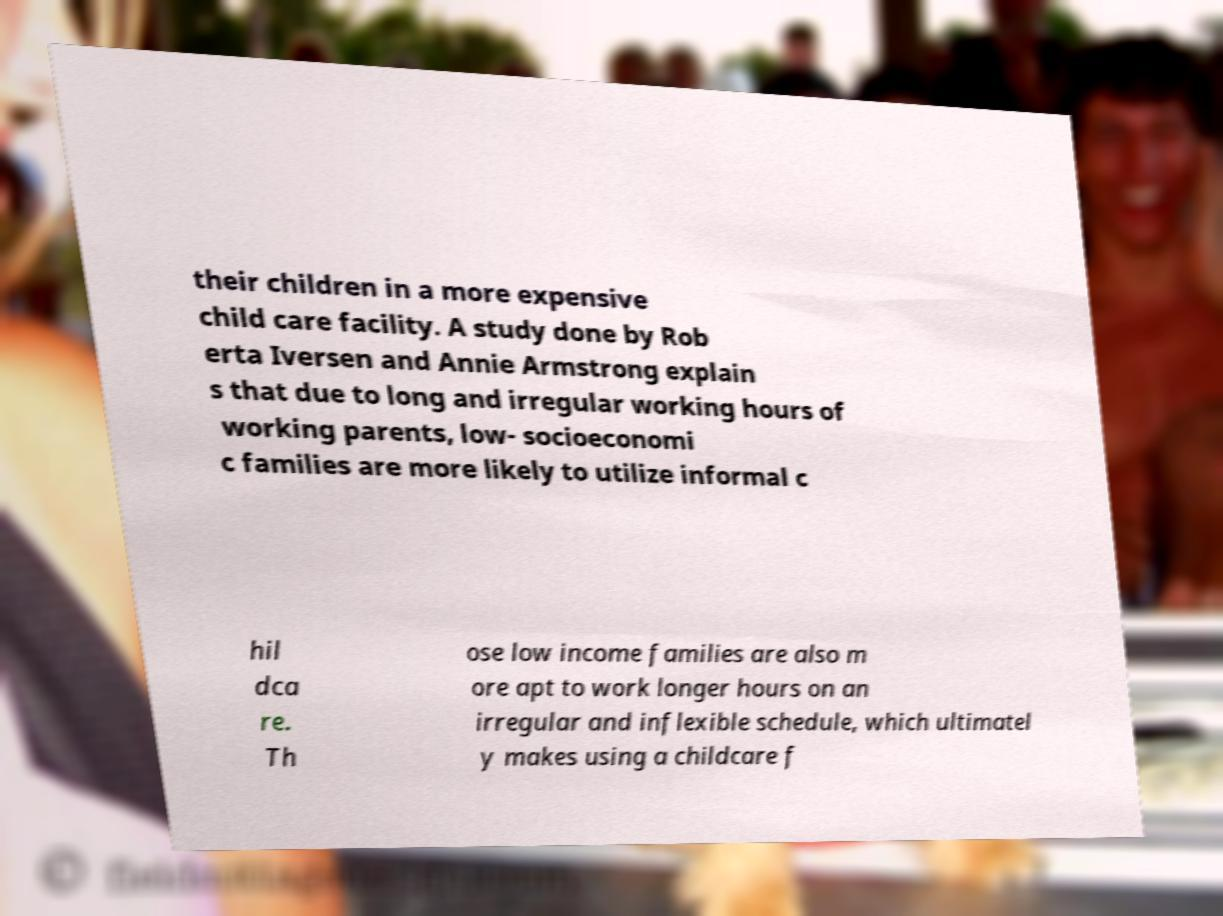There's text embedded in this image that I need extracted. Can you transcribe it verbatim? their children in a more expensive child care facility. A study done by Rob erta Iversen and Annie Armstrong explain s that due to long and irregular working hours of working parents, low- socioeconomi c families are more likely to utilize informal c hil dca re. Th ose low income families are also m ore apt to work longer hours on an irregular and inflexible schedule, which ultimatel y makes using a childcare f 